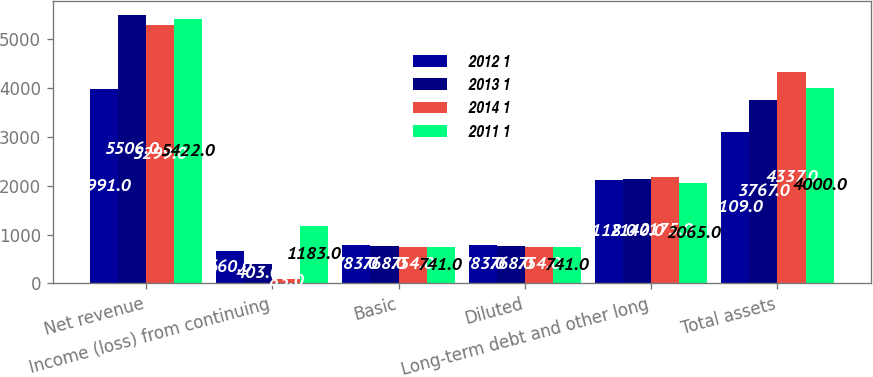<chart> <loc_0><loc_0><loc_500><loc_500><stacked_bar_chart><ecel><fcel>Net revenue<fcel>Income (loss) from continuing<fcel>Basic<fcel>Diluted<fcel>Long-term debt and other long<fcel>Total assets<nl><fcel>2012 1<fcel>3991<fcel>660<fcel>783<fcel>783<fcel>2118<fcel>3109<nl><fcel>2013 1<fcel>5506<fcel>403<fcel>768<fcel>768<fcel>2140<fcel>3767<nl><fcel>2014 1<fcel>5299<fcel>83<fcel>754<fcel>754<fcel>2175<fcel>4337<nl><fcel>2011 1<fcel>5422<fcel>1183<fcel>741<fcel>741<fcel>2065<fcel>4000<nl></chart> 